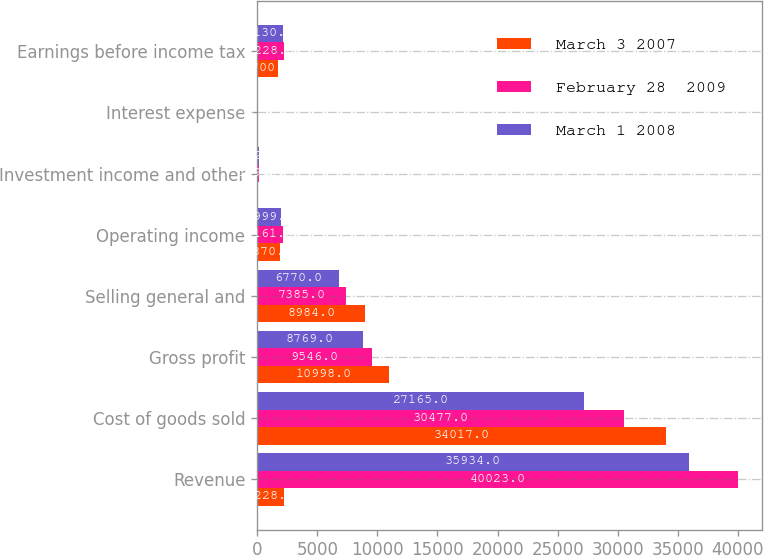Convert chart. <chart><loc_0><loc_0><loc_500><loc_500><stacked_bar_chart><ecel><fcel>Revenue<fcel>Cost of goods sold<fcel>Gross profit<fcel>Selling general and<fcel>Operating income<fcel>Investment income and other<fcel>Interest expense<fcel>Earnings before income tax<nl><fcel>March 3 2007<fcel>2228<fcel>34017<fcel>10998<fcel>8984<fcel>1870<fcel>35<fcel>94<fcel>1700<nl><fcel>February 28  2009<fcel>40023<fcel>30477<fcel>9546<fcel>7385<fcel>2161<fcel>129<fcel>62<fcel>2228<nl><fcel>March 1 2008<fcel>35934<fcel>27165<fcel>8769<fcel>6770<fcel>1999<fcel>162<fcel>31<fcel>2130<nl></chart> 